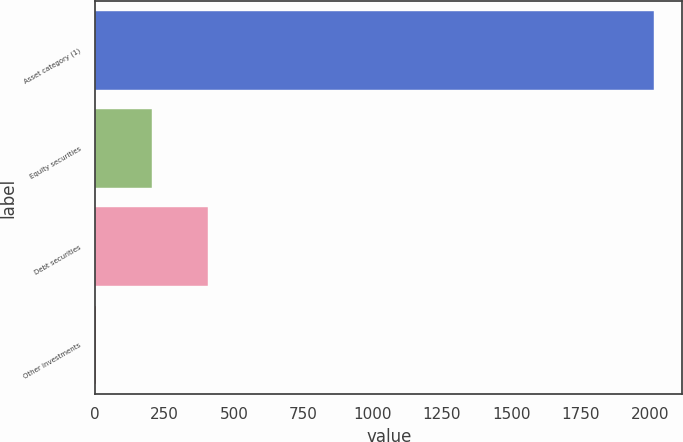<chart> <loc_0><loc_0><loc_500><loc_500><bar_chart><fcel>Asset category (1)<fcel>Equity securities<fcel>Debt securities<fcel>Other investments<nl><fcel>2016<fcel>205.2<fcel>406.4<fcel>4<nl></chart> 